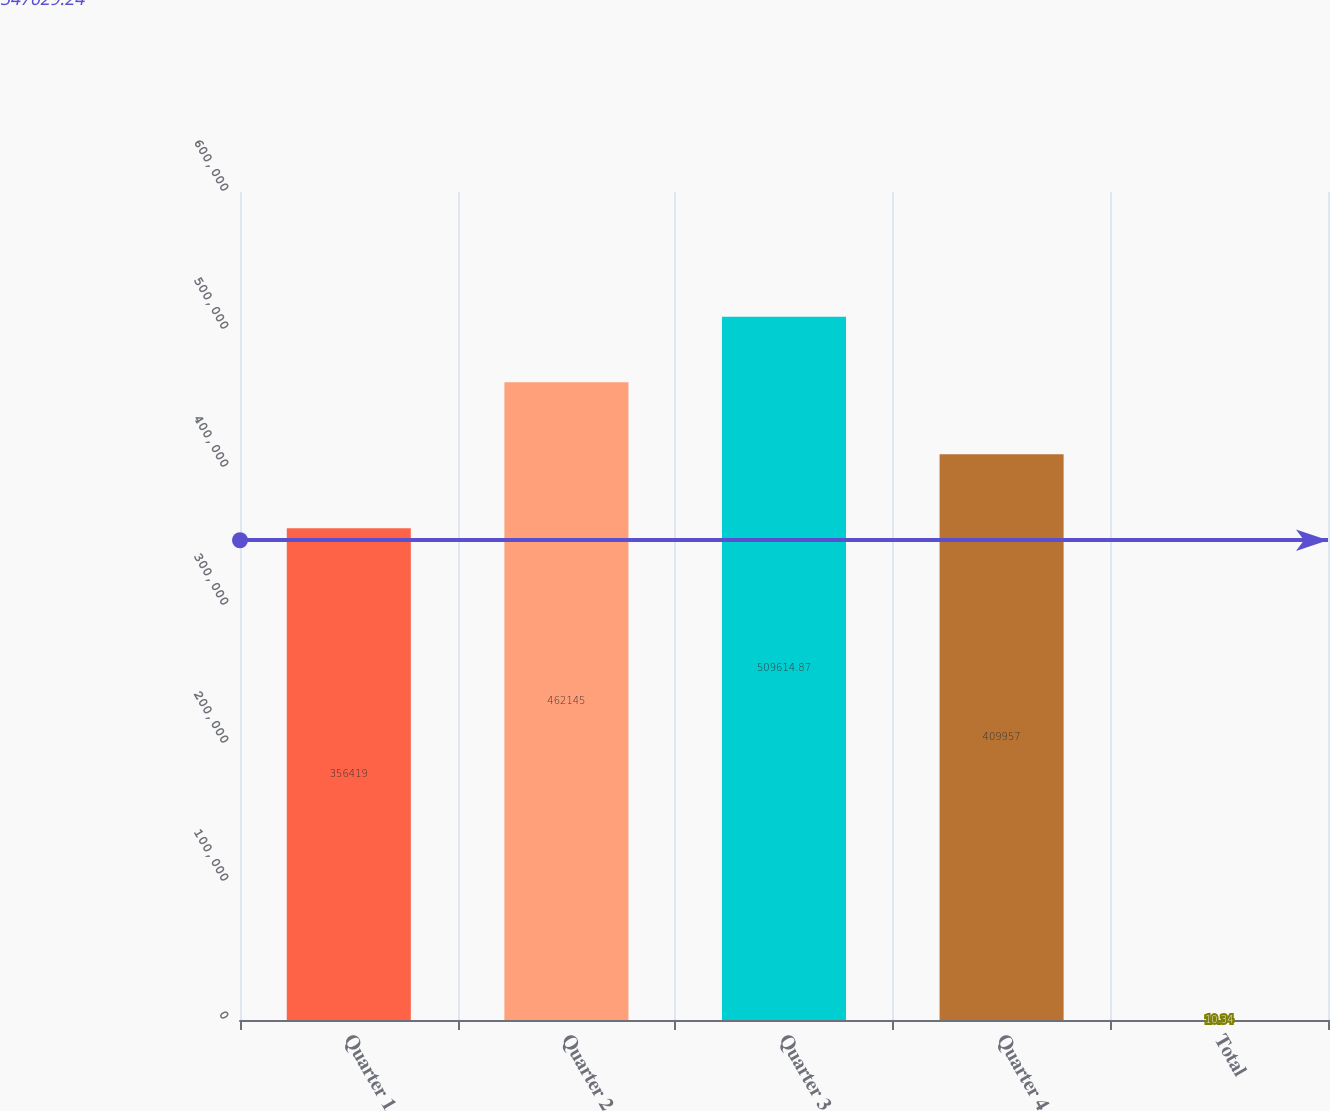<chart> <loc_0><loc_0><loc_500><loc_500><bar_chart><fcel>Quarter 1<fcel>Quarter 2<fcel>Quarter 3<fcel>Quarter 4<fcel>Total<nl><fcel>356419<fcel>462145<fcel>509615<fcel>409957<fcel>10.34<nl></chart> 